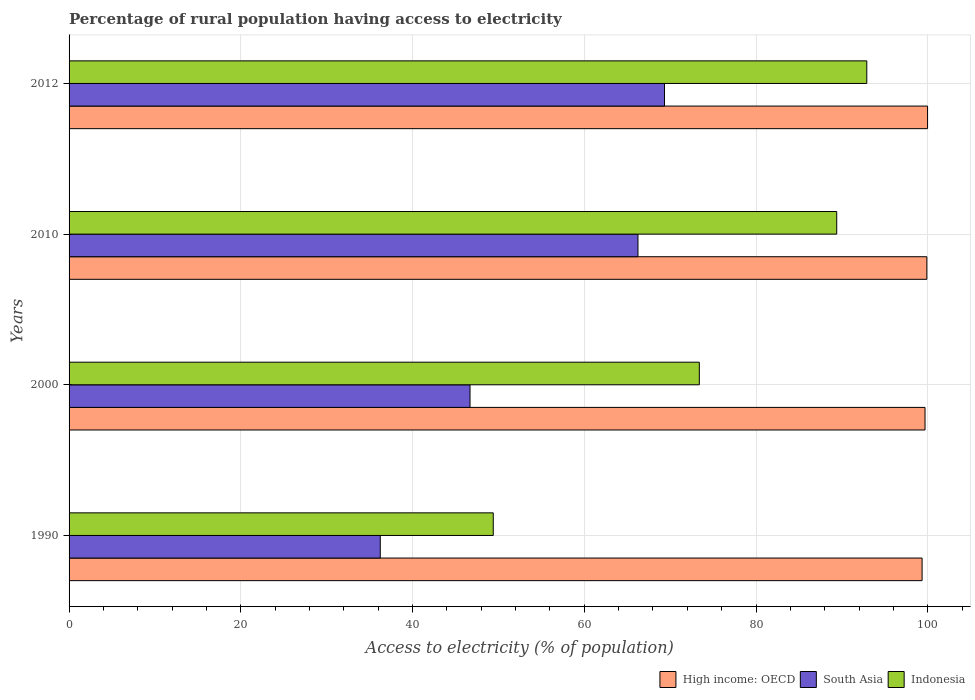Are the number of bars per tick equal to the number of legend labels?
Offer a very short reply. Yes. Are the number of bars on each tick of the Y-axis equal?
Provide a succinct answer. Yes. How many bars are there on the 2nd tick from the top?
Provide a short and direct response. 3. How many bars are there on the 1st tick from the bottom?
Offer a very short reply. 3. What is the label of the 3rd group of bars from the top?
Offer a very short reply. 2000. What is the percentage of rural population having access to electricity in High income: OECD in 2000?
Provide a succinct answer. 99.68. Across all years, what is the maximum percentage of rural population having access to electricity in South Asia?
Offer a terse response. 69.34. Across all years, what is the minimum percentage of rural population having access to electricity in South Asia?
Ensure brevity in your answer.  36.24. What is the total percentage of rural population having access to electricity in Indonesia in the graph?
Your answer should be compact. 305.1. What is the difference between the percentage of rural population having access to electricity in South Asia in 2000 and that in 2012?
Keep it short and to the point. -22.65. What is the difference between the percentage of rural population having access to electricity in High income: OECD in 2010 and the percentage of rural population having access to electricity in Indonesia in 2012?
Your response must be concise. 7. What is the average percentage of rural population having access to electricity in High income: OECD per year?
Your answer should be very brief. 99.73. In the year 2010, what is the difference between the percentage of rural population having access to electricity in Indonesia and percentage of rural population having access to electricity in South Asia?
Give a very brief answer. 23.15. In how many years, is the percentage of rural population having access to electricity in South Asia greater than 48 %?
Provide a short and direct response. 2. What is the ratio of the percentage of rural population having access to electricity in Indonesia in 2000 to that in 2012?
Your answer should be very brief. 0.79. Is the percentage of rural population having access to electricity in Indonesia in 1990 less than that in 2010?
Provide a succinct answer. Yes. Is the difference between the percentage of rural population having access to electricity in Indonesia in 2000 and 2010 greater than the difference between the percentage of rural population having access to electricity in South Asia in 2000 and 2010?
Your answer should be compact. Yes. What is the difference between the highest and the second highest percentage of rural population having access to electricity in High income: OECD?
Ensure brevity in your answer.  0.08. What is the difference between the highest and the lowest percentage of rural population having access to electricity in South Asia?
Your response must be concise. 33.1. What does the 3rd bar from the bottom in 2012 represents?
Provide a succinct answer. Indonesia. Is it the case that in every year, the sum of the percentage of rural population having access to electricity in Indonesia and percentage of rural population having access to electricity in South Asia is greater than the percentage of rural population having access to electricity in High income: OECD?
Provide a succinct answer. No. How many bars are there?
Your answer should be very brief. 12. Are all the bars in the graph horizontal?
Provide a short and direct response. Yes. What is the difference between two consecutive major ticks on the X-axis?
Your answer should be compact. 20. Does the graph contain any zero values?
Provide a succinct answer. No. Where does the legend appear in the graph?
Your response must be concise. Bottom right. How many legend labels are there?
Offer a terse response. 3. What is the title of the graph?
Ensure brevity in your answer.  Percentage of rural population having access to electricity. What is the label or title of the X-axis?
Make the answer very short. Access to electricity (% of population). What is the label or title of the Y-axis?
Provide a short and direct response. Years. What is the Access to electricity (% of population) in High income: OECD in 1990?
Provide a succinct answer. 99.34. What is the Access to electricity (% of population) of South Asia in 1990?
Give a very brief answer. 36.24. What is the Access to electricity (% of population) in Indonesia in 1990?
Provide a short and direct response. 49.4. What is the Access to electricity (% of population) of High income: OECD in 2000?
Provide a short and direct response. 99.68. What is the Access to electricity (% of population) in South Asia in 2000?
Ensure brevity in your answer.  46.69. What is the Access to electricity (% of population) of Indonesia in 2000?
Your answer should be very brief. 73.4. What is the Access to electricity (% of population) of High income: OECD in 2010?
Make the answer very short. 99.9. What is the Access to electricity (% of population) of South Asia in 2010?
Give a very brief answer. 66.25. What is the Access to electricity (% of population) of Indonesia in 2010?
Your answer should be very brief. 89.4. What is the Access to electricity (% of population) in High income: OECD in 2012?
Ensure brevity in your answer.  99.98. What is the Access to electricity (% of population) in South Asia in 2012?
Keep it short and to the point. 69.34. What is the Access to electricity (% of population) of Indonesia in 2012?
Offer a terse response. 92.9. Across all years, what is the maximum Access to electricity (% of population) in High income: OECD?
Give a very brief answer. 99.98. Across all years, what is the maximum Access to electricity (% of population) of South Asia?
Offer a very short reply. 69.34. Across all years, what is the maximum Access to electricity (% of population) of Indonesia?
Provide a succinct answer. 92.9. Across all years, what is the minimum Access to electricity (% of population) in High income: OECD?
Ensure brevity in your answer.  99.34. Across all years, what is the minimum Access to electricity (% of population) of South Asia?
Keep it short and to the point. 36.24. Across all years, what is the minimum Access to electricity (% of population) in Indonesia?
Offer a very short reply. 49.4. What is the total Access to electricity (% of population) in High income: OECD in the graph?
Your response must be concise. 398.9. What is the total Access to electricity (% of population) in South Asia in the graph?
Your response must be concise. 218.53. What is the total Access to electricity (% of population) in Indonesia in the graph?
Keep it short and to the point. 305.1. What is the difference between the Access to electricity (% of population) of High income: OECD in 1990 and that in 2000?
Give a very brief answer. -0.34. What is the difference between the Access to electricity (% of population) in South Asia in 1990 and that in 2000?
Make the answer very short. -10.45. What is the difference between the Access to electricity (% of population) of Indonesia in 1990 and that in 2000?
Make the answer very short. -24. What is the difference between the Access to electricity (% of population) in High income: OECD in 1990 and that in 2010?
Your answer should be compact. -0.55. What is the difference between the Access to electricity (% of population) in South Asia in 1990 and that in 2010?
Ensure brevity in your answer.  -30.01. What is the difference between the Access to electricity (% of population) of High income: OECD in 1990 and that in 2012?
Ensure brevity in your answer.  -0.64. What is the difference between the Access to electricity (% of population) in South Asia in 1990 and that in 2012?
Your answer should be compact. -33.1. What is the difference between the Access to electricity (% of population) of Indonesia in 1990 and that in 2012?
Make the answer very short. -43.5. What is the difference between the Access to electricity (% of population) in High income: OECD in 2000 and that in 2010?
Provide a succinct answer. -0.21. What is the difference between the Access to electricity (% of population) in South Asia in 2000 and that in 2010?
Your answer should be very brief. -19.56. What is the difference between the Access to electricity (% of population) of Indonesia in 2000 and that in 2010?
Make the answer very short. -16. What is the difference between the Access to electricity (% of population) of High income: OECD in 2000 and that in 2012?
Ensure brevity in your answer.  -0.3. What is the difference between the Access to electricity (% of population) of South Asia in 2000 and that in 2012?
Give a very brief answer. -22.65. What is the difference between the Access to electricity (% of population) in Indonesia in 2000 and that in 2012?
Your answer should be compact. -19.5. What is the difference between the Access to electricity (% of population) in High income: OECD in 2010 and that in 2012?
Your answer should be compact. -0.08. What is the difference between the Access to electricity (% of population) in South Asia in 2010 and that in 2012?
Keep it short and to the point. -3.09. What is the difference between the Access to electricity (% of population) in Indonesia in 2010 and that in 2012?
Ensure brevity in your answer.  -3.5. What is the difference between the Access to electricity (% of population) of High income: OECD in 1990 and the Access to electricity (% of population) of South Asia in 2000?
Make the answer very short. 52.65. What is the difference between the Access to electricity (% of population) in High income: OECD in 1990 and the Access to electricity (% of population) in Indonesia in 2000?
Provide a short and direct response. 25.94. What is the difference between the Access to electricity (% of population) of South Asia in 1990 and the Access to electricity (% of population) of Indonesia in 2000?
Provide a short and direct response. -37.16. What is the difference between the Access to electricity (% of population) in High income: OECD in 1990 and the Access to electricity (% of population) in South Asia in 2010?
Offer a terse response. 33.09. What is the difference between the Access to electricity (% of population) in High income: OECD in 1990 and the Access to electricity (% of population) in Indonesia in 2010?
Provide a succinct answer. 9.94. What is the difference between the Access to electricity (% of population) of South Asia in 1990 and the Access to electricity (% of population) of Indonesia in 2010?
Offer a terse response. -53.16. What is the difference between the Access to electricity (% of population) in High income: OECD in 1990 and the Access to electricity (% of population) in South Asia in 2012?
Provide a succinct answer. 30. What is the difference between the Access to electricity (% of population) in High income: OECD in 1990 and the Access to electricity (% of population) in Indonesia in 2012?
Give a very brief answer. 6.44. What is the difference between the Access to electricity (% of population) in South Asia in 1990 and the Access to electricity (% of population) in Indonesia in 2012?
Your answer should be compact. -56.66. What is the difference between the Access to electricity (% of population) in High income: OECD in 2000 and the Access to electricity (% of population) in South Asia in 2010?
Offer a very short reply. 33.43. What is the difference between the Access to electricity (% of population) in High income: OECD in 2000 and the Access to electricity (% of population) in Indonesia in 2010?
Your answer should be very brief. 10.28. What is the difference between the Access to electricity (% of population) of South Asia in 2000 and the Access to electricity (% of population) of Indonesia in 2010?
Offer a very short reply. -42.71. What is the difference between the Access to electricity (% of population) of High income: OECD in 2000 and the Access to electricity (% of population) of South Asia in 2012?
Ensure brevity in your answer.  30.34. What is the difference between the Access to electricity (% of population) in High income: OECD in 2000 and the Access to electricity (% of population) in Indonesia in 2012?
Make the answer very short. 6.78. What is the difference between the Access to electricity (% of population) in South Asia in 2000 and the Access to electricity (% of population) in Indonesia in 2012?
Provide a short and direct response. -46.21. What is the difference between the Access to electricity (% of population) of High income: OECD in 2010 and the Access to electricity (% of population) of South Asia in 2012?
Provide a succinct answer. 30.55. What is the difference between the Access to electricity (% of population) in High income: OECD in 2010 and the Access to electricity (% of population) in Indonesia in 2012?
Your answer should be compact. 7. What is the difference between the Access to electricity (% of population) in South Asia in 2010 and the Access to electricity (% of population) in Indonesia in 2012?
Offer a terse response. -26.65. What is the average Access to electricity (% of population) of High income: OECD per year?
Offer a very short reply. 99.73. What is the average Access to electricity (% of population) in South Asia per year?
Your answer should be very brief. 54.63. What is the average Access to electricity (% of population) in Indonesia per year?
Give a very brief answer. 76.28. In the year 1990, what is the difference between the Access to electricity (% of population) in High income: OECD and Access to electricity (% of population) in South Asia?
Your response must be concise. 63.1. In the year 1990, what is the difference between the Access to electricity (% of population) in High income: OECD and Access to electricity (% of population) in Indonesia?
Provide a succinct answer. 49.94. In the year 1990, what is the difference between the Access to electricity (% of population) in South Asia and Access to electricity (% of population) in Indonesia?
Your answer should be compact. -13.16. In the year 2000, what is the difference between the Access to electricity (% of population) of High income: OECD and Access to electricity (% of population) of South Asia?
Give a very brief answer. 52.99. In the year 2000, what is the difference between the Access to electricity (% of population) in High income: OECD and Access to electricity (% of population) in Indonesia?
Your response must be concise. 26.28. In the year 2000, what is the difference between the Access to electricity (% of population) of South Asia and Access to electricity (% of population) of Indonesia?
Your response must be concise. -26.71. In the year 2010, what is the difference between the Access to electricity (% of population) in High income: OECD and Access to electricity (% of population) in South Asia?
Your response must be concise. 33.64. In the year 2010, what is the difference between the Access to electricity (% of population) in High income: OECD and Access to electricity (% of population) in Indonesia?
Your answer should be very brief. 10.5. In the year 2010, what is the difference between the Access to electricity (% of population) in South Asia and Access to electricity (% of population) in Indonesia?
Give a very brief answer. -23.15. In the year 2012, what is the difference between the Access to electricity (% of population) of High income: OECD and Access to electricity (% of population) of South Asia?
Keep it short and to the point. 30.64. In the year 2012, what is the difference between the Access to electricity (% of population) in High income: OECD and Access to electricity (% of population) in Indonesia?
Offer a terse response. 7.08. In the year 2012, what is the difference between the Access to electricity (% of population) of South Asia and Access to electricity (% of population) of Indonesia?
Provide a succinct answer. -23.56. What is the ratio of the Access to electricity (% of population) of High income: OECD in 1990 to that in 2000?
Your response must be concise. 1. What is the ratio of the Access to electricity (% of population) in South Asia in 1990 to that in 2000?
Offer a terse response. 0.78. What is the ratio of the Access to electricity (% of population) in Indonesia in 1990 to that in 2000?
Provide a short and direct response. 0.67. What is the ratio of the Access to electricity (% of population) of South Asia in 1990 to that in 2010?
Provide a succinct answer. 0.55. What is the ratio of the Access to electricity (% of population) of Indonesia in 1990 to that in 2010?
Provide a short and direct response. 0.55. What is the ratio of the Access to electricity (% of population) of South Asia in 1990 to that in 2012?
Ensure brevity in your answer.  0.52. What is the ratio of the Access to electricity (% of population) in Indonesia in 1990 to that in 2012?
Provide a short and direct response. 0.53. What is the ratio of the Access to electricity (% of population) of South Asia in 2000 to that in 2010?
Provide a succinct answer. 0.7. What is the ratio of the Access to electricity (% of population) of Indonesia in 2000 to that in 2010?
Give a very brief answer. 0.82. What is the ratio of the Access to electricity (% of population) in High income: OECD in 2000 to that in 2012?
Provide a short and direct response. 1. What is the ratio of the Access to electricity (% of population) of South Asia in 2000 to that in 2012?
Ensure brevity in your answer.  0.67. What is the ratio of the Access to electricity (% of population) in Indonesia in 2000 to that in 2012?
Provide a succinct answer. 0.79. What is the ratio of the Access to electricity (% of population) in South Asia in 2010 to that in 2012?
Make the answer very short. 0.96. What is the ratio of the Access to electricity (% of population) of Indonesia in 2010 to that in 2012?
Provide a succinct answer. 0.96. What is the difference between the highest and the second highest Access to electricity (% of population) in High income: OECD?
Keep it short and to the point. 0.08. What is the difference between the highest and the second highest Access to electricity (% of population) in South Asia?
Offer a very short reply. 3.09. What is the difference between the highest and the second highest Access to electricity (% of population) in Indonesia?
Make the answer very short. 3.5. What is the difference between the highest and the lowest Access to electricity (% of population) in High income: OECD?
Offer a very short reply. 0.64. What is the difference between the highest and the lowest Access to electricity (% of population) of South Asia?
Keep it short and to the point. 33.1. What is the difference between the highest and the lowest Access to electricity (% of population) of Indonesia?
Keep it short and to the point. 43.5. 